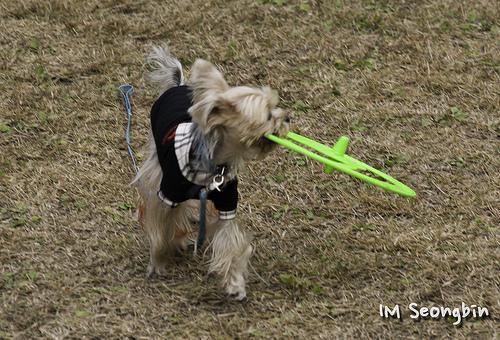How many dogs are there?
Give a very brief answer. 1. 